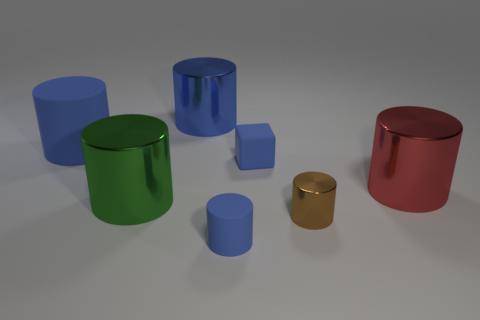Subtract all purple spheres. How many blue cylinders are left? 3 Subtract all brown metal cylinders. How many cylinders are left? 5 Subtract all green cylinders. How many cylinders are left? 5 Subtract all yellow cylinders. Subtract all red cubes. How many cylinders are left? 6 Add 1 large blue objects. How many objects exist? 8 Subtract all cubes. How many objects are left? 6 Subtract 0 purple cubes. How many objects are left? 7 Subtract all small brown things. Subtract all large blue rubber cylinders. How many objects are left? 5 Add 1 small blue things. How many small blue things are left? 3 Add 3 small rubber cylinders. How many small rubber cylinders exist? 4 